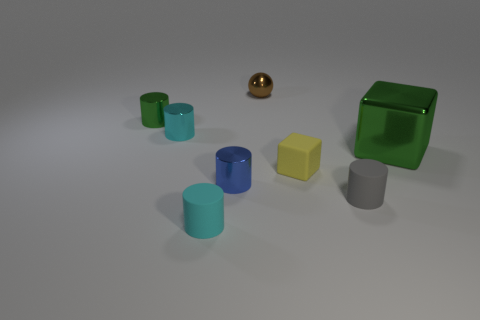Subtract all blue cylinders. How many cylinders are left? 4 Subtract all cyan matte cylinders. How many cylinders are left? 4 Subtract all yellow cylinders. Subtract all purple balls. How many cylinders are left? 5 Add 1 tiny cyan matte cylinders. How many objects exist? 9 Subtract all blocks. How many objects are left? 6 Add 1 tiny green objects. How many tiny green objects exist? 2 Subtract 0 brown cubes. How many objects are left? 8 Subtract all brown blocks. Subtract all rubber blocks. How many objects are left? 7 Add 7 gray rubber objects. How many gray rubber objects are left? 8 